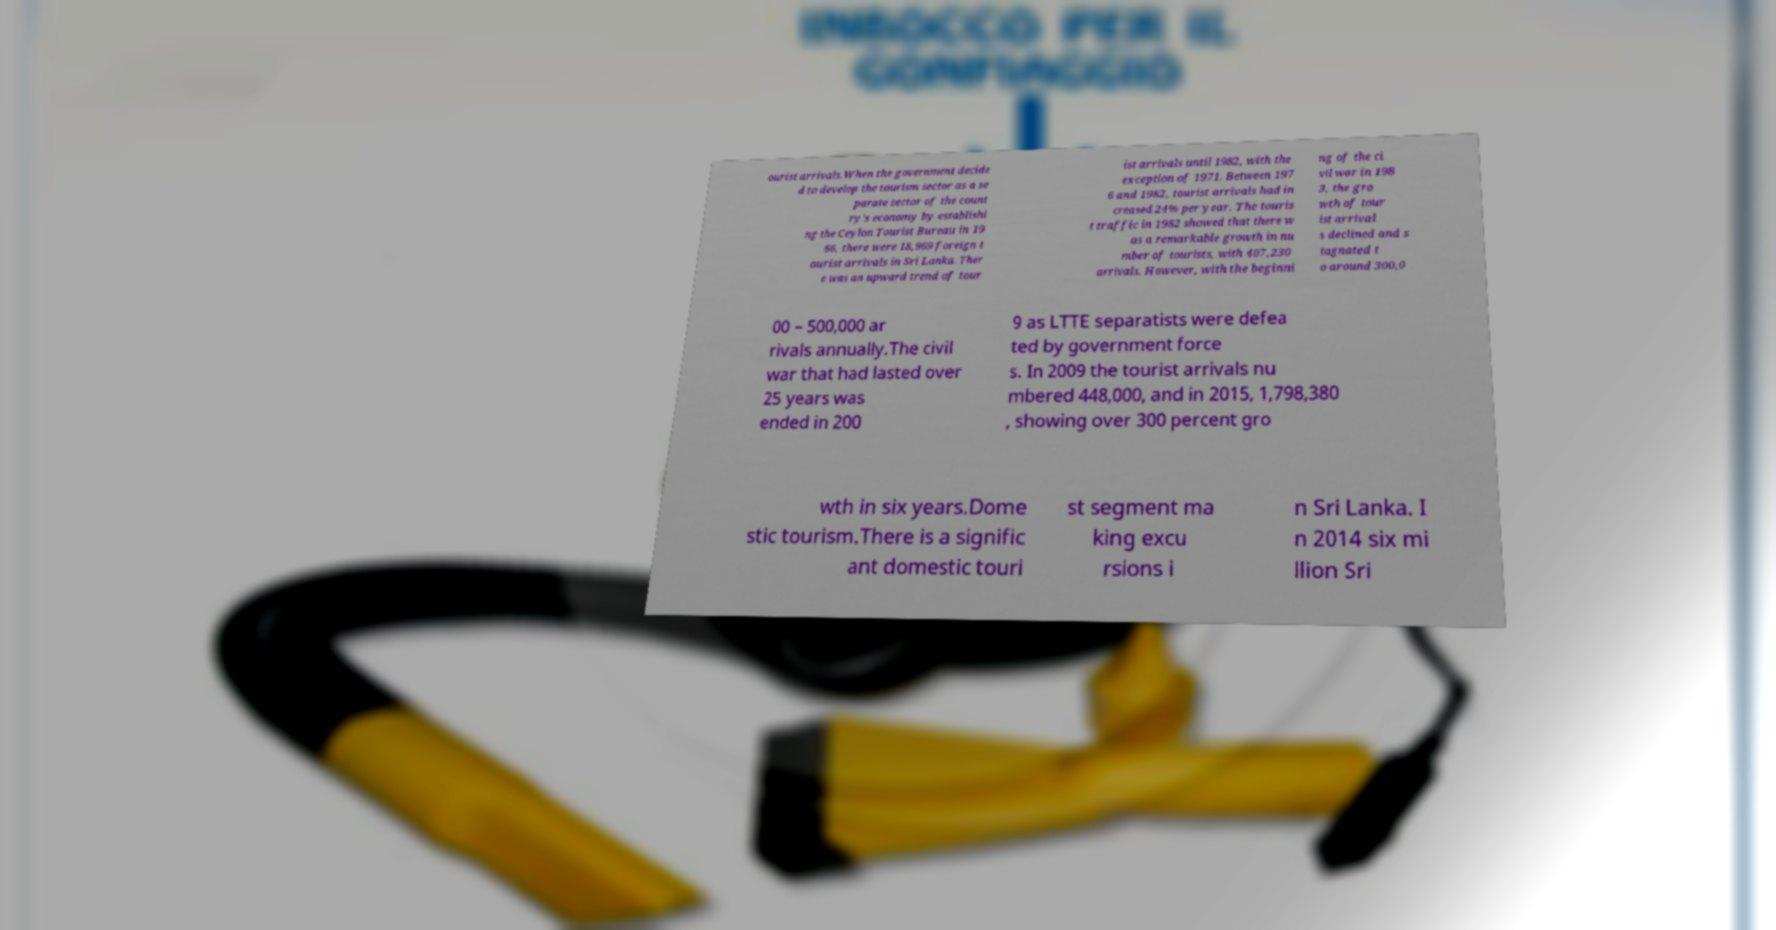Could you extract and type out the text from this image? ourist arrivals.When the government decide d to develop the tourism sector as a se parate sector of the count ry's economy by establishi ng the Ceylon Tourist Bureau in 19 66, there were 18,969 foreign t ourist arrivals in Sri Lanka. Ther e was an upward trend of tour ist arrivals until 1982, with the exception of 1971. Between 197 6 and 1982, tourist arrivals had in creased 24% per year. The touris t traffic in 1982 showed that there w as a remarkable growth in nu mber of tourists, with 407,230 arrivals. However, with the beginni ng of the ci vil war in 198 3, the gro wth of tour ist arrival s declined and s tagnated t o around 300,0 00 – 500,000 ar rivals annually.The civil war that had lasted over 25 years was ended in 200 9 as LTTE separatists were defea ted by government force s. In 2009 the tourist arrivals nu mbered 448,000, and in 2015, 1,798,380 , showing over 300 percent gro wth in six years.Dome stic tourism.There is a signific ant domestic touri st segment ma king excu rsions i n Sri Lanka. I n 2014 six mi llion Sri 